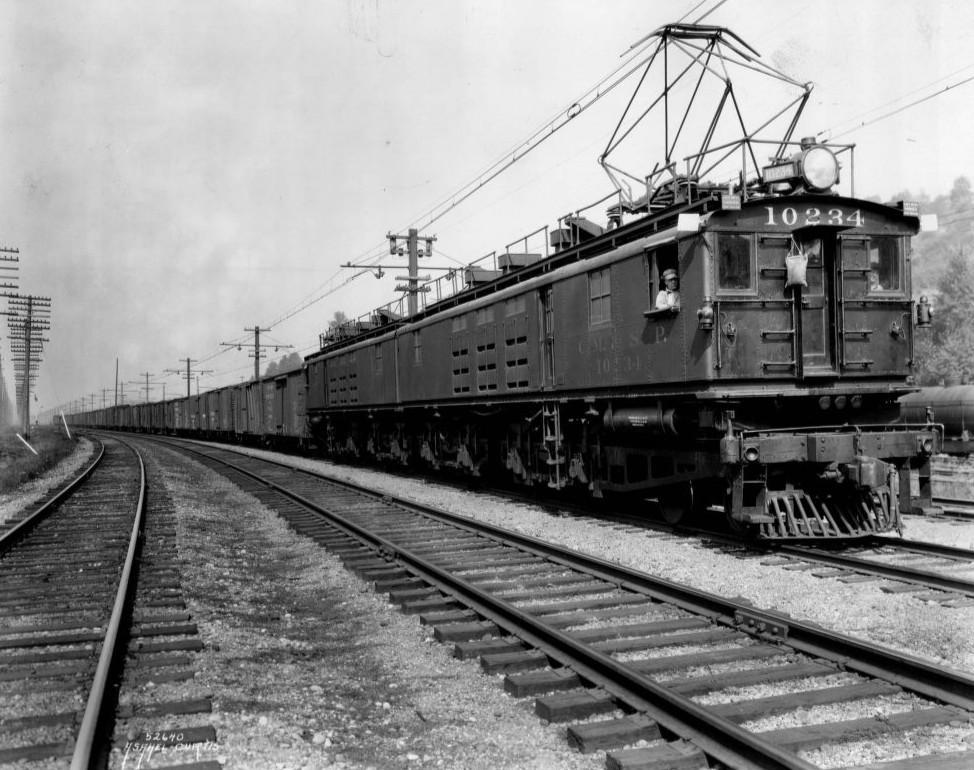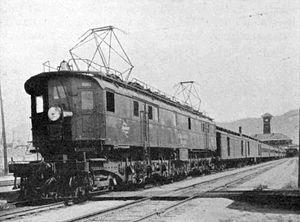The first image is the image on the left, the second image is the image on the right. Considering the images on both sides, is "None of the trains are near a light pole." valid? Answer yes or no. Yes. The first image is the image on the left, the second image is the image on the right. Evaluate the accuracy of this statement regarding the images: "The trains in the right and left images are headed in completely different directions.". Is it true? Answer yes or no. Yes. 